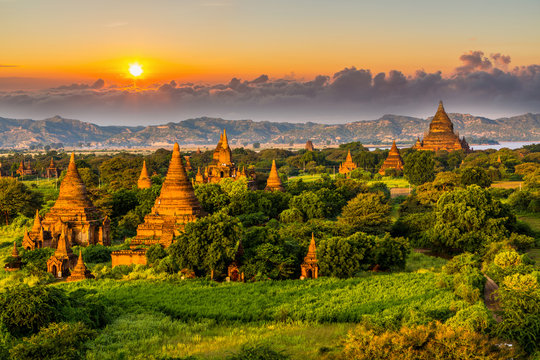What is the ideal time of day to visit this location to experience a similar view as shown in the image? The ideal time to experience a view similar to the one in the image is during the early morning or late afternoon. These times offer soft, golden lighting due to the sun’s low position in the sky, which not only enhances the beauty of the temples but also creates a tranquil and reflective atmosphere, perfect for photography or simply appreciating the serene environment. 